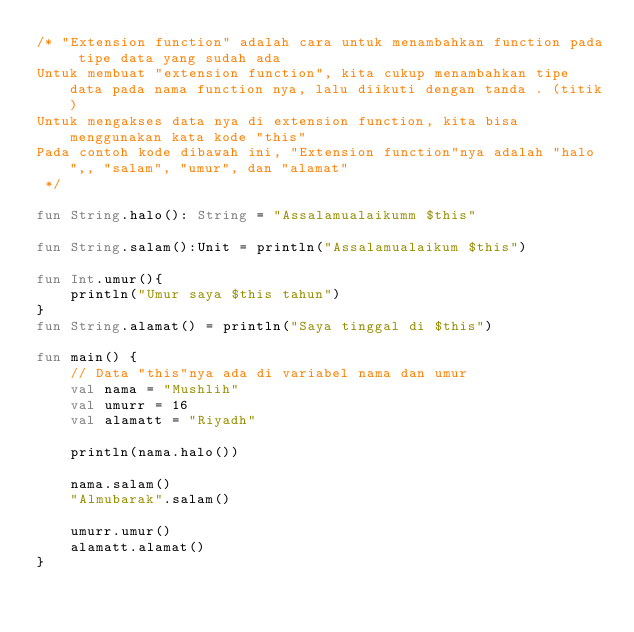<code> <loc_0><loc_0><loc_500><loc_500><_Kotlin_>/* "Extension function" adalah cara untuk menambahkan function pada tipe data yang sudah ada
Untuk membuat "extension function", kita cukup menambahkan tipe data pada nama function nya, lalu diikuti dengan tanda . (titik)
Untuk mengakses data nya di extension function, kita bisa menggunakan kata kode "this"
Pada contoh kode dibawah ini, "Extension function"nya adalah "halo",, "salam", "umur", dan "alamat"
 */

fun String.halo(): String = "Assalamualaikumm $this"

fun String.salam():Unit = println("Assalamualaikum $this")

fun Int.umur(){
    println("Umur saya $this tahun")
}
fun String.alamat() = println("Saya tinggal di $this")

fun main() {
    // Data "this"nya ada di variabel nama dan umur
    val nama = "Mushlih"
    val umurr = 16
    val alamatt = "Riyadh"

    println(nama.halo())

    nama.salam()
    "Almubarak".salam()

    umurr.umur()
    alamatt.alamat()
}</code> 